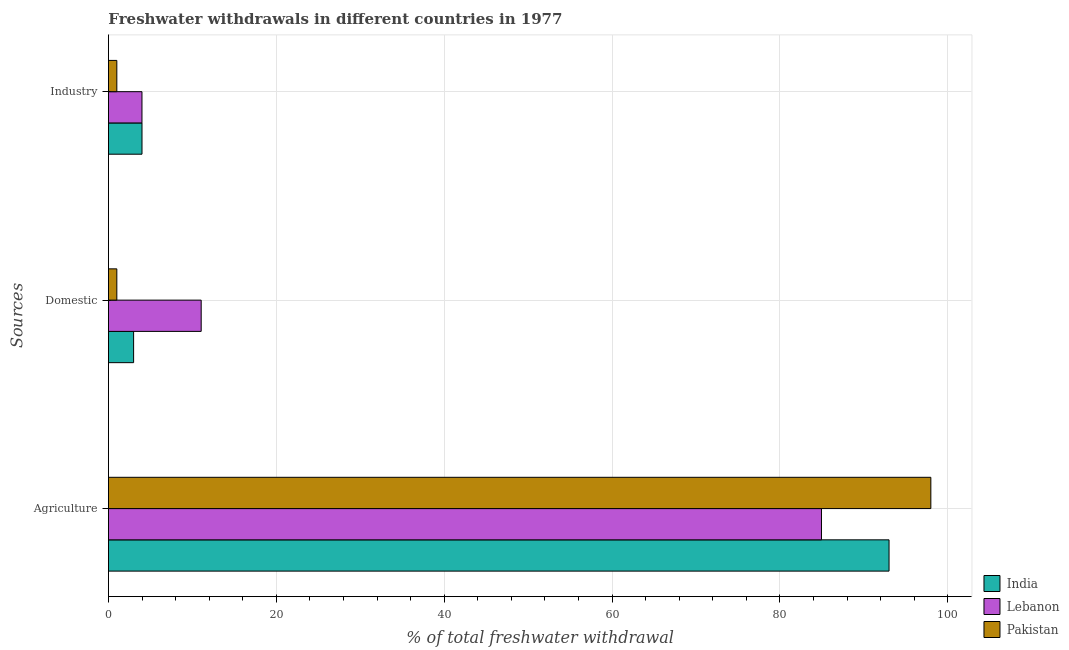Are the number of bars per tick equal to the number of legend labels?
Keep it short and to the point. Yes. Are the number of bars on each tick of the Y-axis equal?
Your answer should be compact. Yes. How many bars are there on the 2nd tick from the bottom?
Provide a succinct answer. 3. What is the label of the 2nd group of bars from the top?
Your answer should be compact. Domestic. What is the percentage of freshwater withdrawal for agriculture in India?
Offer a very short reply. 93. Across all countries, what is the maximum percentage of freshwater withdrawal for domestic purposes?
Your response must be concise. 11.05. Across all countries, what is the minimum percentage of freshwater withdrawal for agriculture?
Keep it short and to the point. 84.95. What is the total percentage of freshwater withdrawal for agriculture in the graph?
Offer a very short reply. 275.93. What is the difference between the percentage of freshwater withdrawal for domestic purposes in India and that in Pakistan?
Make the answer very short. 2. What is the average percentage of freshwater withdrawal for industry per country?
Provide a short and direct response. 3. What is the ratio of the percentage of freshwater withdrawal for industry in India to that in Pakistan?
Your answer should be very brief. 4. Is the difference between the percentage of freshwater withdrawal for industry in Pakistan and India greater than the difference between the percentage of freshwater withdrawal for agriculture in Pakistan and India?
Your response must be concise. No. What is the difference between the highest and the second highest percentage of freshwater withdrawal for industry?
Your response must be concise. 0. What does the 1st bar from the top in Domestic represents?
Provide a succinct answer. Pakistan. What does the 3rd bar from the bottom in Industry represents?
Provide a short and direct response. Pakistan. Is it the case that in every country, the sum of the percentage of freshwater withdrawal for agriculture and percentage of freshwater withdrawal for domestic purposes is greater than the percentage of freshwater withdrawal for industry?
Give a very brief answer. Yes. How many bars are there?
Make the answer very short. 9. Does the graph contain any zero values?
Keep it short and to the point. No. Does the graph contain grids?
Provide a short and direct response. Yes. Where does the legend appear in the graph?
Offer a very short reply. Bottom right. How many legend labels are there?
Give a very brief answer. 3. What is the title of the graph?
Offer a terse response. Freshwater withdrawals in different countries in 1977. Does "Angola" appear as one of the legend labels in the graph?
Provide a succinct answer. No. What is the label or title of the X-axis?
Your answer should be very brief. % of total freshwater withdrawal. What is the label or title of the Y-axis?
Make the answer very short. Sources. What is the % of total freshwater withdrawal of India in Agriculture?
Make the answer very short. 93. What is the % of total freshwater withdrawal in Lebanon in Agriculture?
Offer a very short reply. 84.95. What is the % of total freshwater withdrawal in Pakistan in Agriculture?
Your answer should be compact. 97.98. What is the % of total freshwater withdrawal of Lebanon in Domestic?
Your answer should be compact. 11.05. What is the % of total freshwater withdrawal of India in Industry?
Give a very brief answer. 4. What is the % of total freshwater withdrawal of Lebanon in Industry?
Offer a terse response. 4. Across all Sources, what is the maximum % of total freshwater withdrawal of India?
Provide a short and direct response. 93. Across all Sources, what is the maximum % of total freshwater withdrawal of Lebanon?
Your answer should be very brief. 84.95. Across all Sources, what is the maximum % of total freshwater withdrawal of Pakistan?
Offer a very short reply. 97.98. Across all Sources, what is the minimum % of total freshwater withdrawal in Lebanon?
Give a very brief answer. 4. Across all Sources, what is the minimum % of total freshwater withdrawal of Pakistan?
Offer a terse response. 1. What is the total % of total freshwater withdrawal in Lebanon in the graph?
Your response must be concise. 100. What is the total % of total freshwater withdrawal in Pakistan in the graph?
Keep it short and to the point. 99.98. What is the difference between the % of total freshwater withdrawal in Lebanon in Agriculture and that in Domestic?
Provide a short and direct response. 73.9. What is the difference between the % of total freshwater withdrawal in Pakistan in Agriculture and that in Domestic?
Ensure brevity in your answer.  96.98. What is the difference between the % of total freshwater withdrawal in India in Agriculture and that in Industry?
Your answer should be very brief. 89. What is the difference between the % of total freshwater withdrawal of Lebanon in Agriculture and that in Industry?
Offer a very short reply. 80.95. What is the difference between the % of total freshwater withdrawal in Pakistan in Agriculture and that in Industry?
Your response must be concise. 96.98. What is the difference between the % of total freshwater withdrawal in India in Domestic and that in Industry?
Your response must be concise. -1. What is the difference between the % of total freshwater withdrawal of Lebanon in Domestic and that in Industry?
Keep it short and to the point. 7.05. What is the difference between the % of total freshwater withdrawal of Pakistan in Domestic and that in Industry?
Your answer should be very brief. 0. What is the difference between the % of total freshwater withdrawal in India in Agriculture and the % of total freshwater withdrawal in Lebanon in Domestic?
Your response must be concise. 81.95. What is the difference between the % of total freshwater withdrawal of India in Agriculture and the % of total freshwater withdrawal of Pakistan in Domestic?
Offer a very short reply. 92. What is the difference between the % of total freshwater withdrawal of Lebanon in Agriculture and the % of total freshwater withdrawal of Pakistan in Domestic?
Your answer should be very brief. 83.95. What is the difference between the % of total freshwater withdrawal of India in Agriculture and the % of total freshwater withdrawal of Lebanon in Industry?
Your answer should be very brief. 89. What is the difference between the % of total freshwater withdrawal in India in Agriculture and the % of total freshwater withdrawal in Pakistan in Industry?
Your response must be concise. 92. What is the difference between the % of total freshwater withdrawal of Lebanon in Agriculture and the % of total freshwater withdrawal of Pakistan in Industry?
Your answer should be very brief. 83.95. What is the difference between the % of total freshwater withdrawal in India in Domestic and the % of total freshwater withdrawal in Lebanon in Industry?
Keep it short and to the point. -0.99. What is the difference between the % of total freshwater withdrawal of India in Domestic and the % of total freshwater withdrawal of Pakistan in Industry?
Ensure brevity in your answer.  2. What is the difference between the % of total freshwater withdrawal of Lebanon in Domestic and the % of total freshwater withdrawal of Pakistan in Industry?
Provide a short and direct response. 10.05. What is the average % of total freshwater withdrawal of India per Sources?
Your answer should be very brief. 33.33. What is the average % of total freshwater withdrawal of Lebanon per Sources?
Make the answer very short. 33.33. What is the average % of total freshwater withdrawal in Pakistan per Sources?
Your answer should be compact. 33.33. What is the difference between the % of total freshwater withdrawal of India and % of total freshwater withdrawal of Lebanon in Agriculture?
Make the answer very short. 8.05. What is the difference between the % of total freshwater withdrawal of India and % of total freshwater withdrawal of Pakistan in Agriculture?
Ensure brevity in your answer.  -4.98. What is the difference between the % of total freshwater withdrawal of Lebanon and % of total freshwater withdrawal of Pakistan in Agriculture?
Keep it short and to the point. -13.03. What is the difference between the % of total freshwater withdrawal in India and % of total freshwater withdrawal in Lebanon in Domestic?
Provide a succinct answer. -8.05. What is the difference between the % of total freshwater withdrawal in Lebanon and % of total freshwater withdrawal in Pakistan in Domestic?
Provide a succinct answer. 10.05. What is the difference between the % of total freshwater withdrawal in India and % of total freshwater withdrawal in Lebanon in Industry?
Keep it short and to the point. 0.01. What is the difference between the % of total freshwater withdrawal in Lebanon and % of total freshwater withdrawal in Pakistan in Industry?
Your answer should be compact. 3. What is the ratio of the % of total freshwater withdrawal of Lebanon in Agriculture to that in Domestic?
Your response must be concise. 7.69. What is the ratio of the % of total freshwater withdrawal in Pakistan in Agriculture to that in Domestic?
Provide a short and direct response. 97.98. What is the ratio of the % of total freshwater withdrawal in India in Agriculture to that in Industry?
Provide a short and direct response. 23.25. What is the ratio of the % of total freshwater withdrawal of Lebanon in Agriculture to that in Industry?
Provide a short and direct response. 21.26. What is the ratio of the % of total freshwater withdrawal of Pakistan in Agriculture to that in Industry?
Make the answer very short. 97.98. What is the ratio of the % of total freshwater withdrawal in India in Domestic to that in Industry?
Keep it short and to the point. 0.75. What is the ratio of the % of total freshwater withdrawal in Lebanon in Domestic to that in Industry?
Give a very brief answer. 2.77. What is the ratio of the % of total freshwater withdrawal in Pakistan in Domestic to that in Industry?
Offer a terse response. 1. What is the difference between the highest and the second highest % of total freshwater withdrawal in India?
Offer a terse response. 89. What is the difference between the highest and the second highest % of total freshwater withdrawal of Lebanon?
Give a very brief answer. 73.9. What is the difference between the highest and the second highest % of total freshwater withdrawal in Pakistan?
Make the answer very short. 96.98. What is the difference between the highest and the lowest % of total freshwater withdrawal of Lebanon?
Give a very brief answer. 80.95. What is the difference between the highest and the lowest % of total freshwater withdrawal of Pakistan?
Offer a very short reply. 96.98. 